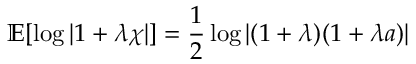Convert formula to latex. <formula><loc_0><loc_0><loc_500><loc_500>\mathbb { E } [ \log | 1 + \lambda \chi | ] = \frac { 1 } { 2 } \log \left | ( 1 + \lambda ) ( 1 + \lambda a ) \right |</formula> 